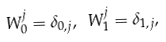Convert formula to latex. <formula><loc_0><loc_0><loc_500><loc_500>W _ { 0 } ^ { j } = \delta _ { 0 , j } , \ W _ { 1 } ^ { j } = \delta _ { 1 , j } ,</formula> 